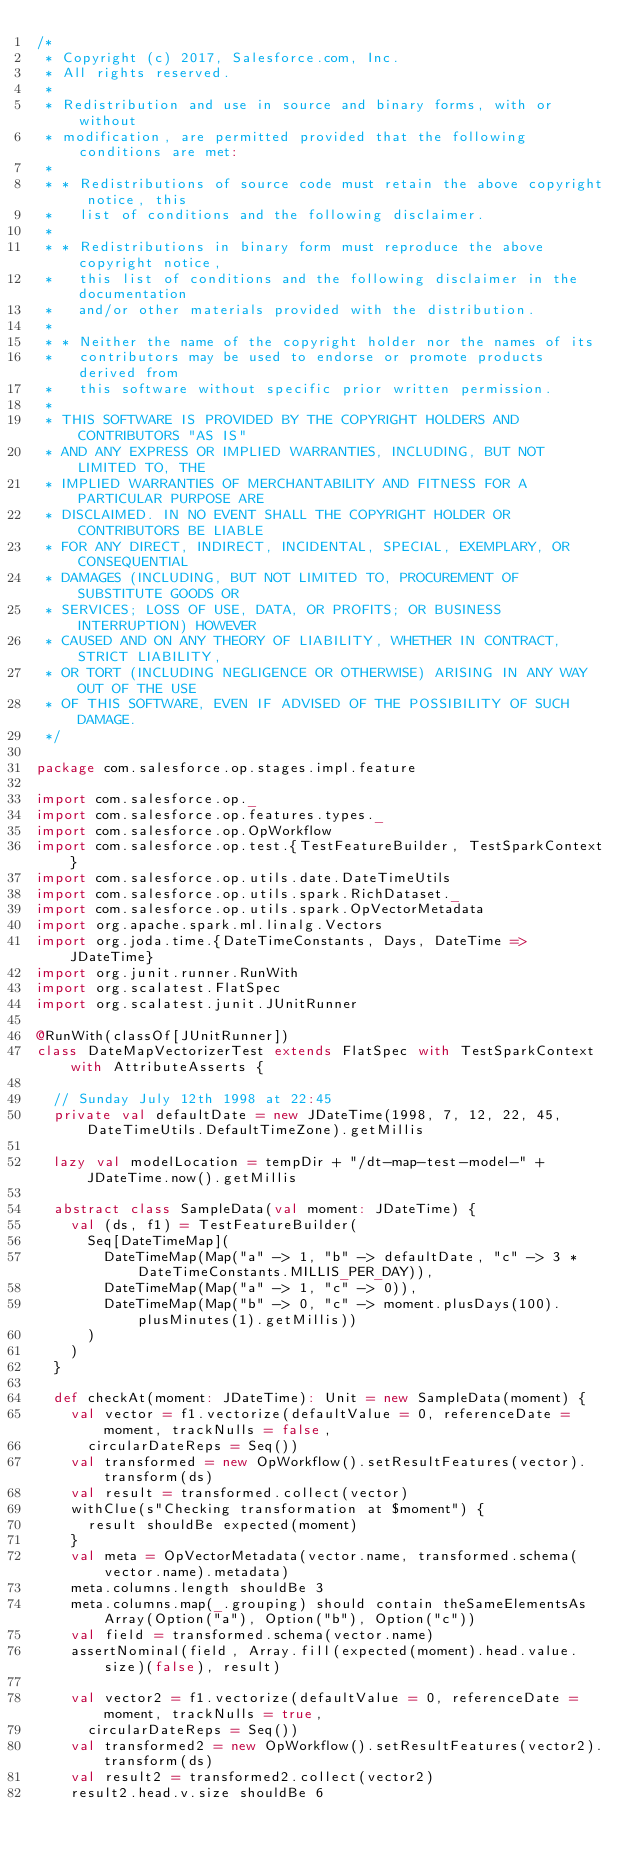<code> <loc_0><loc_0><loc_500><loc_500><_Scala_>/*
 * Copyright (c) 2017, Salesforce.com, Inc.
 * All rights reserved.
 *
 * Redistribution and use in source and binary forms, with or without
 * modification, are permitted provided that the following conditions are met:
 *
 * * Redistributions of source code must retain the above copyright notice, this
 *   list of conditions and the following disclaimer.
 *
 * * Redistributions in binary form must reproduce the above copyright notice,
 *   this list of conditions and the following disclaimer in the documentation
 *   and/or other materials provided with the distribution.
 *
 * * Neither the name of the copyright holder nor the names of its
 *   contributors may be used to endorse or promote products derived from
 *   this software without specific prior written permission.
 *
 * THIS SOFTWARE IS PROVIDED BY THE COPYRIGHT HOLDERS AND CONTRIBUTORS "AS IS"
 * AND ANY EXPRESS OR IMPLIED WARRANTIES, INCLUDING, BUT NOT LIMITED TO, THE
 * IMPLIED WARRANTIES OF MERCHANTABILITY AND FITNESS FOR A PARTICULAR PURPOSE ARE
 * DISCLAIMED. IN NO EVENT SHALL THE COPYRIGHT HOLDER OR CONTRIBUTORS BE LIABLE
 * FOR ANY DIRECT, INDIRECT, INCIDENTAL, SPECIAL, EXEMPLARY, OR CONSEQUENTIAL
 * DAMAGES (INCLUDING, BUT NOT LIMITED TO, PROCUREMENT OF SUBSTITUTE GOODS OR
 * SERVICES; LOSS OF USE, DATA, OR PROFITS; OR BUSINESS INTERRUPTION) HOWEVER
 * CAUSED AND ON ANY THEORY OF LIABILITY, WHETHER IN CONTRACT, STRICT LIABILITY,
 * OR TORT (INCLUDING NEGLIGENCE OR OTHERWISE) ARISING IN ANY WAY OUT OF THE USE
 * OF THIS SOFTWARE, EVEN IF ADVISED OF THE POSSIBILITY OF SUCH DAMAGE.
 */

package com.salesforce.op.stages.impl.feature

import com.salesforce.op._
import com.salesforce.op.features.types._
import com.salesforce.op.OpWorkflow
import com.salesforce.op.test.{TestFeatureBuilder, TestSparkContext}
import com.salesforce.op.utils.date.DateTimeUtils
import com.salesforce.op.utils.spark.RichDataset._
import com.salesforce.op.utils.spark.OpVectorMetadata
import org.apache.spark.ml.linalg.Vectors
import org.joda.time.{DateTimeConstants, Days, DateTime => JDateTime}
import org.junit.runner.RunWith
import org.scalatest.FlatSpec
import org.scalatest.junit.JUnitRunner

@RunWith(classOf[JUnitRunner])
class DateMapVectorizerTest extends FlatSpec with TestSparkContext with AttributeAsserts {

  // Sunday July 12th 1998 at 22:45
  private val defaultDate = new JDateTime(1998, 7, 12, 22, 45, DateTimeUtils.DefaultTimeZone).getMillis

  lazy val modelLocation = tempDir + "/dt-map-test-model-" + JDateTime.now().getMillis

  abstract class SampleData(val moment: JDateTime) {
    val (ds, f1) = TestFeatureBuilder(
      Seq[DateTimeMap](
        DateTimeMap(Map("a" -> 1, "b" -> defaultDate, "c" -> 3 * DateTimeConstants.MILLIS_PER_DAY)),
        DateTimeMap(Map("a" -> 1, "c" -> 0)),
        DateTimeMap(Map("b" -> 0, "c" -> moment.plusDays(100).plusMinutes(1).getMillis))
      )
    )
  }

  def checkAt(moment: JDateTime): Unit = new SampleData(moment) {
    val vector = f1.vectorize(defaultValue = 0, referenceDate = moment, trackNulls = false,
      circularDateReps = Seq())
    val transformed = new OpWorkflow().setResultFeatures(vector).transform(ds)
    val result = transformed.collect(vector)
    withClue(s"Checking transformation at $moment") {
      result shouldBe expected(moment)
    }
    val meta = OpVectorMetadata(vector.name, transformed.schema(vector.name).metadata)
    meta.columns.length shouldBe 3
    meta.columns.map(_.grouping) should contain theSameElementsAs Array(Option("a"), Option("b"), Option("c"))
    val field = transformed.schema(vector.name)
    assertNominal(field, Array.fill(expected(moment).head.value.size)(false), result)

    val vector2 = f1.vectorize(defaultValue = 0, referenceDate = moment, trackNulls = true,
      circularDateReps = Seq())
    val transformed2 = new OpWorkflow().setResultFeatures(vector2).transform(ds)
    val result2 = transformed2.collect(vector2)
    result2.head.v.size shouldBe 6
</code> 